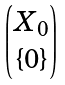Convert formula to latex. <formula><loc_0><loc_0><loc_500><loc_500>\begin{pmatrix} X _ { 0 } \\ \{ 0 \} \end{pmatrix}</formula> 